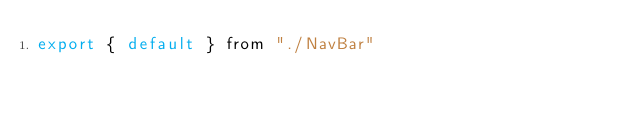Convert code to text. <code><loc_0><loc_0><loc_500><loc_500><_JavaScript_>export { default } from "./NavBar"</code> 